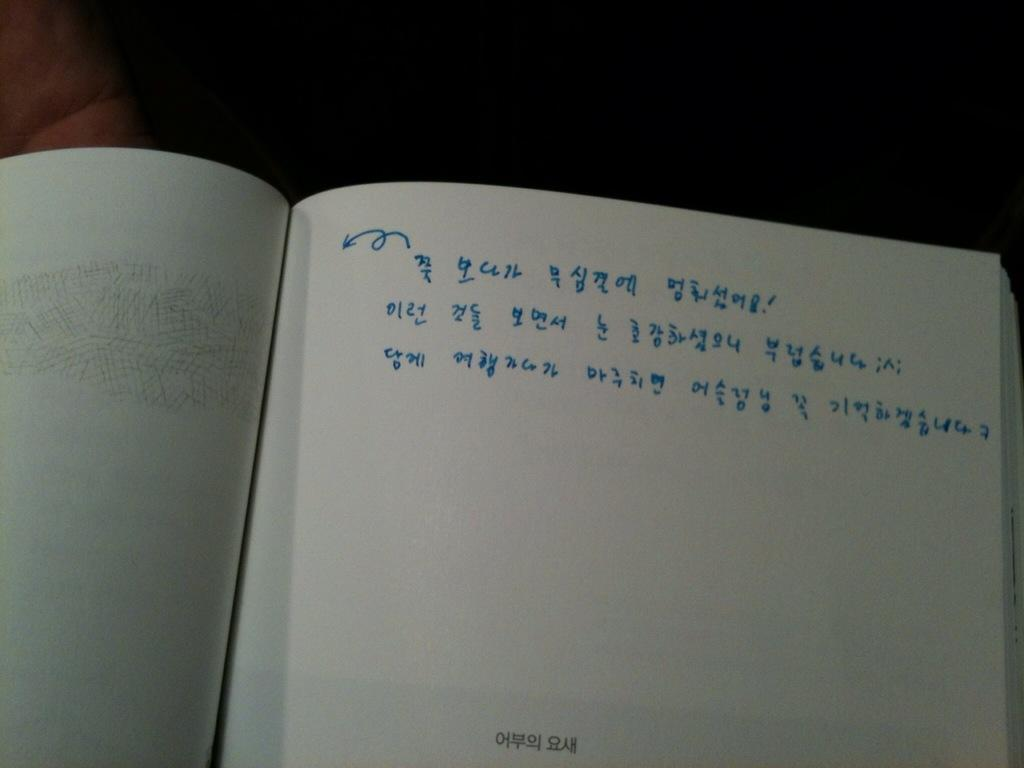<image>
Create a compact narrative representing the image presented. Seven is the last number in a long number sequence written on a page. 